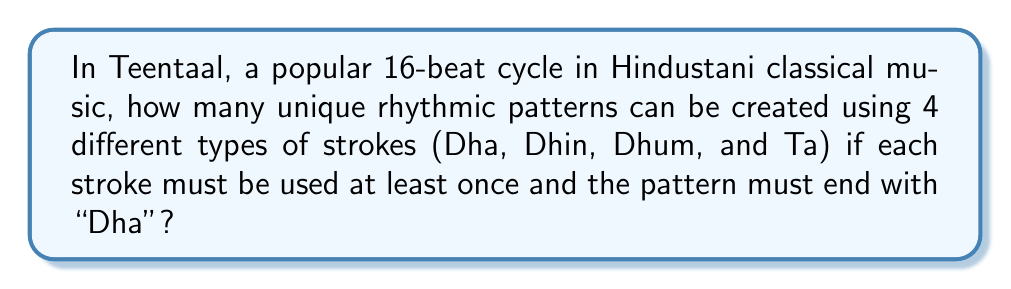Help me with this question. Let's approach this problem step-by-step using combinatorics:

1) We have 16 beats in total, and the last beat must be "Dha".

2) We need to use each of the 4 strokes at least once. This means we've accounted for 4 beats (including the last "Dha").

3) We now have 12 remaining beats to fill with any of the 4 strokes.

4) This is a problem of distributing 12 identical objects (remaining beats) into 4 distinct boxes (types of strokes). This is equivalent to finding the number of ways to choose 3 dividers among 15 positions (12 objects + 3 dividers = 15 positions).

5) This can be solved using the combination formula:

   $$\binom{15}{3} = \frac{15!}{3!(15-3)!} = \frac{15!}{3!12!}$$

6) Calculating this:
   $$\frac{15 * 14 * 13}{3 * 2 * 1} = \frac{2730}{6} = 455$$

Therefore, there are 455 unique rhythmic patterns that satisfy the given conditions in Teentaal.
Answer: 455 